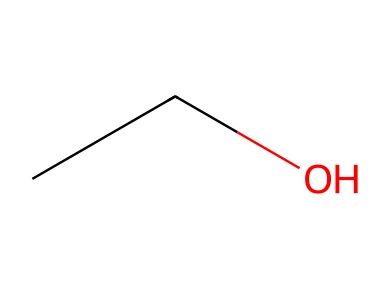What is the molecular formula of this compound? The given SMILES notation (CCO) indicates the presence of two carbon atoms (C), six hydrogen atoms (H), and one oxygen atom (O), leading to the formula C2H6O.
Answer: C2H6O How many hydrogen atoms are present in ethanol? In the structure represented by the SMILES (CCO), two carbon atoms are each bonded to three hydrogen atoms, plus one additional hydrogen bonded to the hydroxyl (-OH) group, totaling six hydrogen atoms.
Answer: 6 What functional group is present in ethanol? The SMILES notation shows a hydroxyl (-OH) group connected to a carbon chain, characteristic of alcohols. Therefore, the functional group in ethanol is an alcohol.
Answer: alcohol Is ethanol a polar or nonpolar molecule? The presence of the hydroxyl (-OH) group introduces a polar character to the molecule due to the difference in electronegativity between oxygen and hydrogen, while the carbon chain contributes a relatively nonpolar aspect. However, the overall molecule is predominantly polar.
Answer: polar What type of bonding is primarily found in ethanol? Analyzing the SMILES structure (CCO), the main types of bonds present are covalent bonds between the carbon and hydrogen atoms, as well as the carbon and oxygen atoms.
Answer: covalent How many carbon atoms are in ethanol? The SMILES notation (CCO) clearly delineates two 'C' characters, indicating that there are two carbon atoms present in the structure of ethanol.
Answer: 2 What type of compound is ethanol classified as? Ethanol, with its hydroxyl group and carbon backbone, is classified as an alcohol within organic chemistry.
Answer: alcohol 